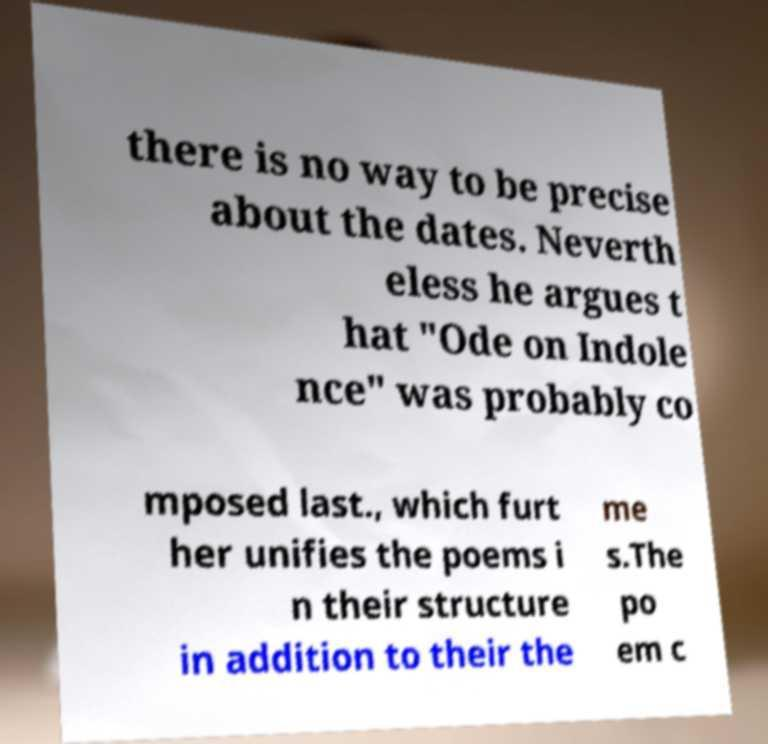Please identify and transcribe the text found in this image. there is no way to be precise about the dates. Neverth eless he argues t hat "Ode on Indole nce" was probably co mposed last., which furt her unifies the poems i n their structure in addition to their the me s.The po em c 